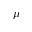Convert formula to latex. <formula><loc_0><loc_0><loc_500><loc_500>\mu</formula> 